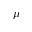Convert formula to latex. <formula><loc_0><loc_0><loc_500><loc_500>\mu</formula> 